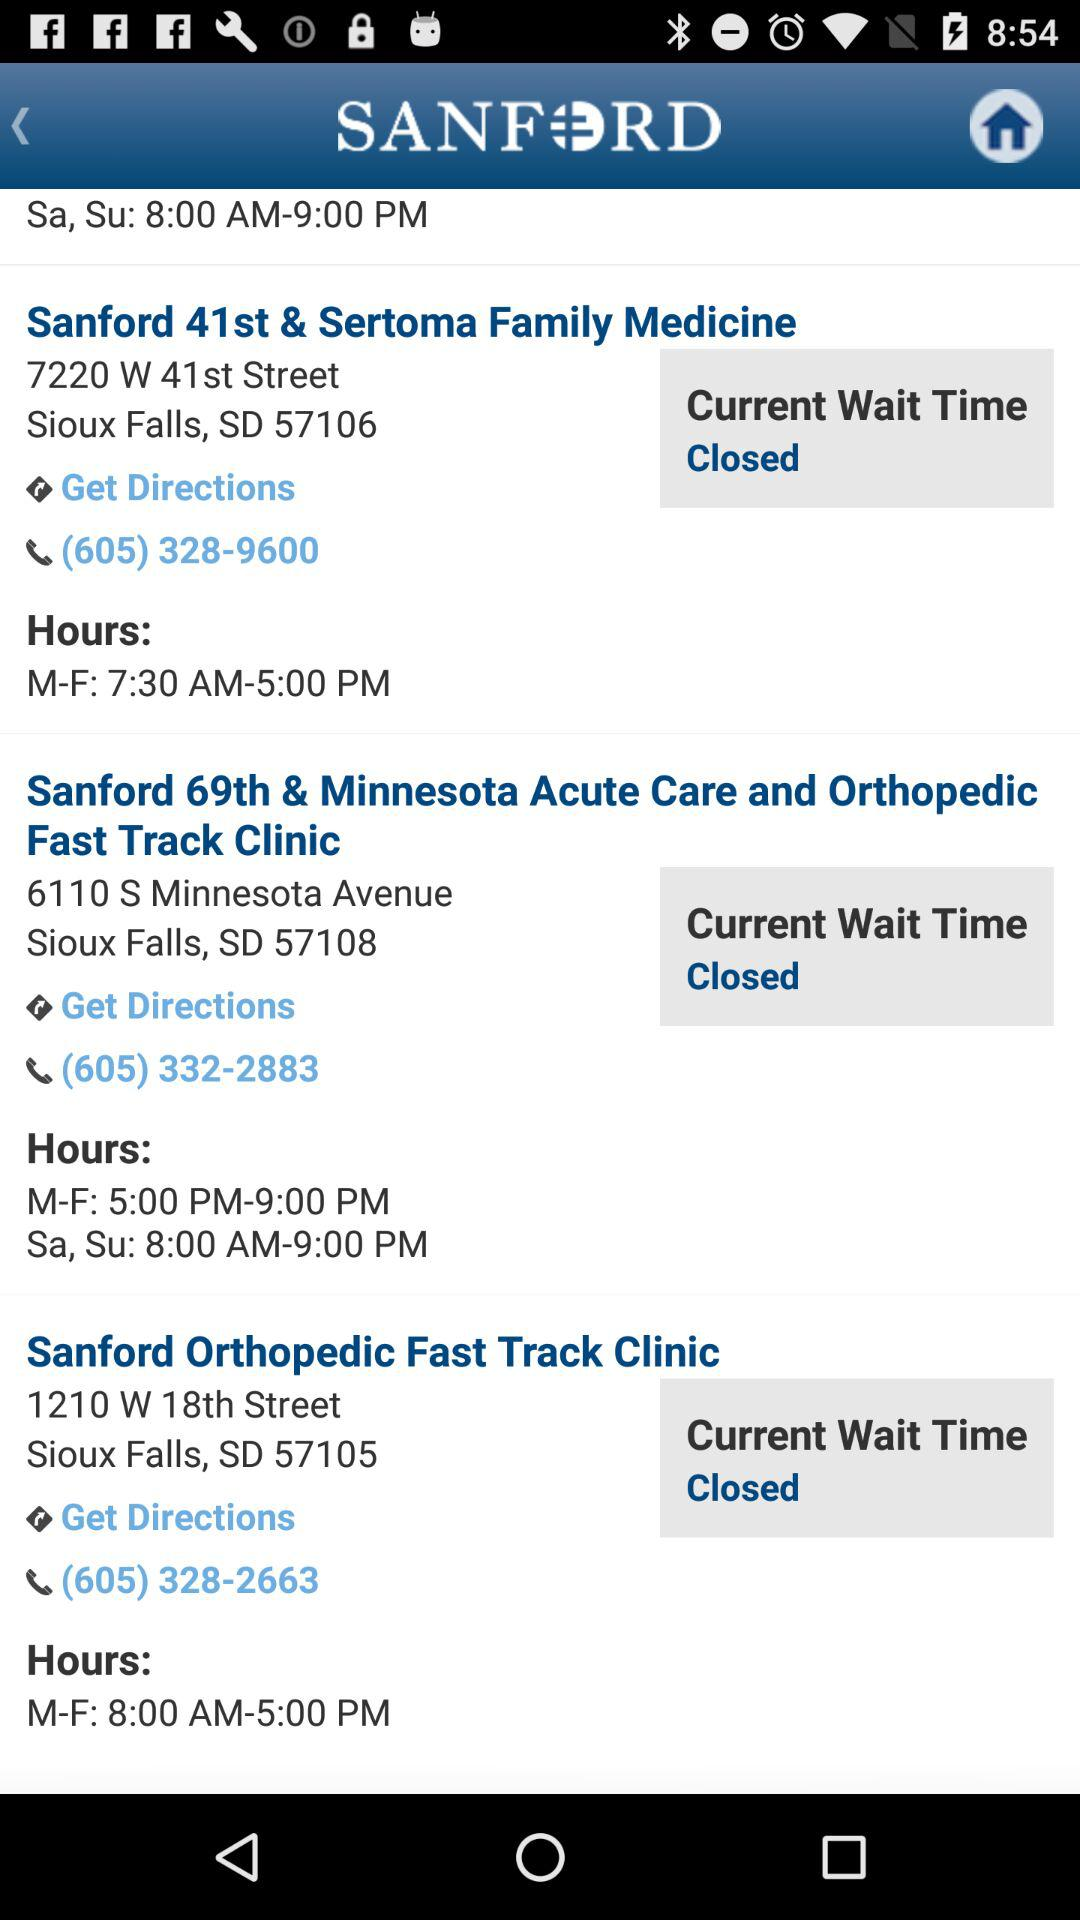What are Sanford 41st & Sertoma Family Medicine working hours? The working hours are 7:30 AM–5:00 PM. 